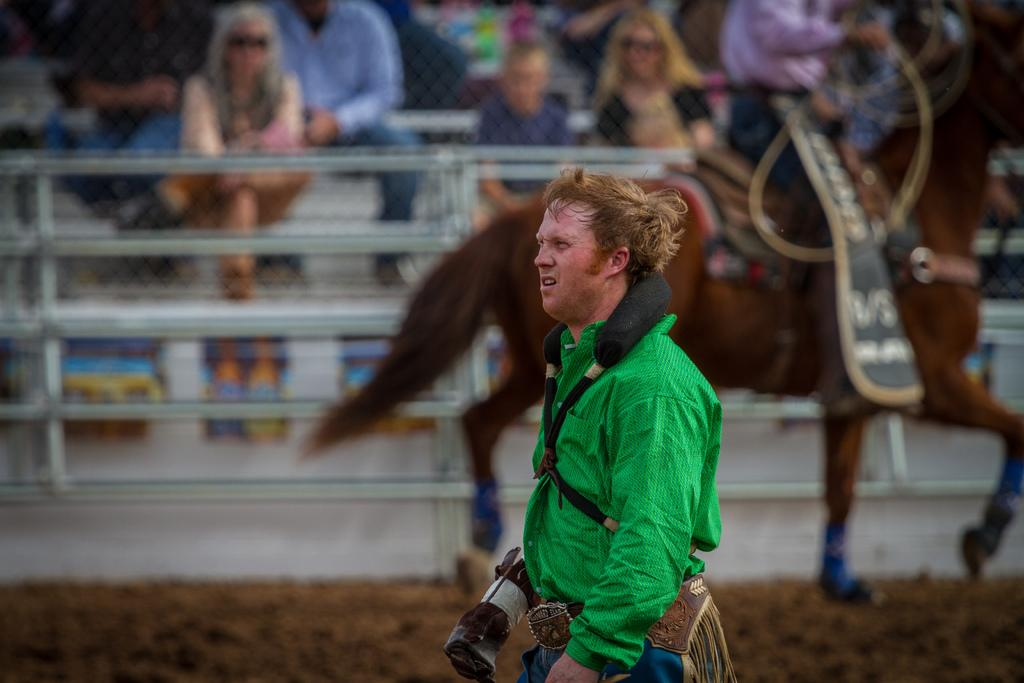Who is the main subject in the image? There is a man standing in the center of the image. What is located behind the man? There is a horse behind the man. Can you describe the people in the background of the image? There are people sitting in the background of the image. What type of iron is being used by the man in the image? There is no iron present in the image; the man is standing next to a horse. 